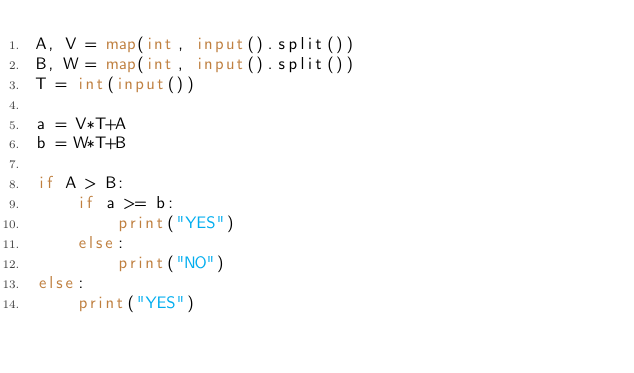Convert code to text. <code><loc_0><loc_0><loc_500><loc_500><_Python_>A, V = map(int, input().split())
B, W = map(int, input().split())
T = int(input())

a = V*T+A
b = W*T+B

if A > B:
    if a >= b:
        print("YES")
    else:
        print("NO")
else:
    print("YES")</code> 